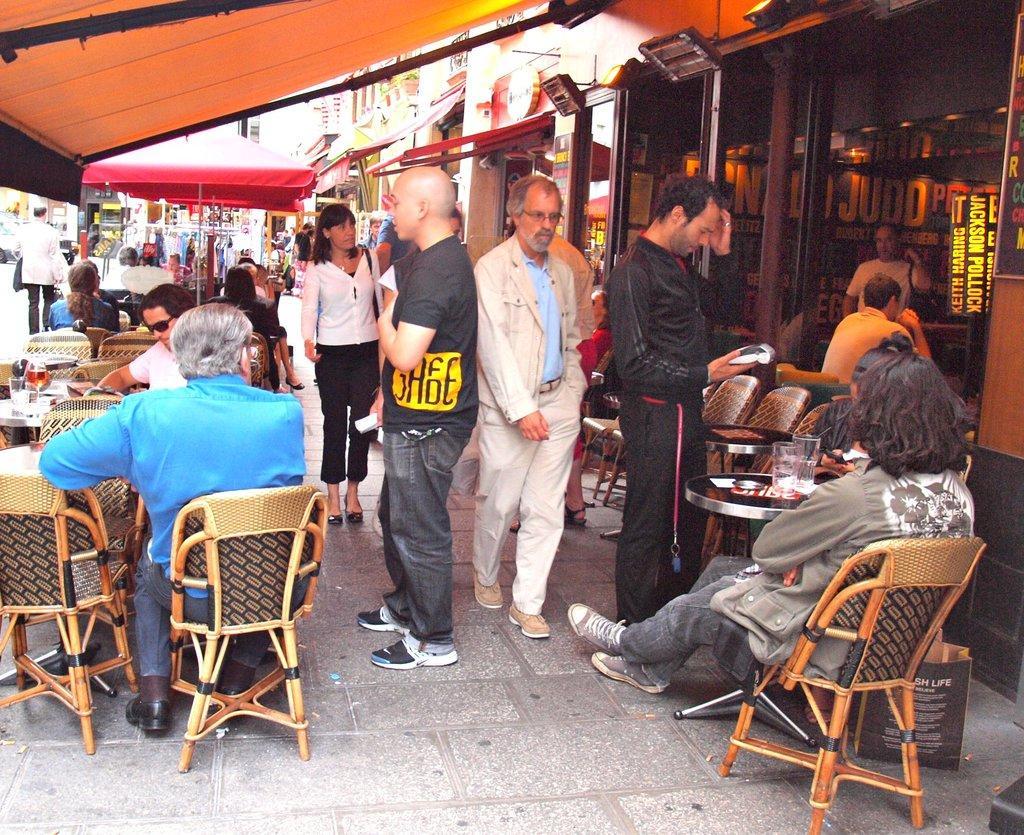How would you summarize this image in a sentence or two? This picture describes about group of people, few are seated on the chair and few are standing, in front of them we can find couple of glasses on the table, in the background we can see couple of tents, buildings and vehicles. 